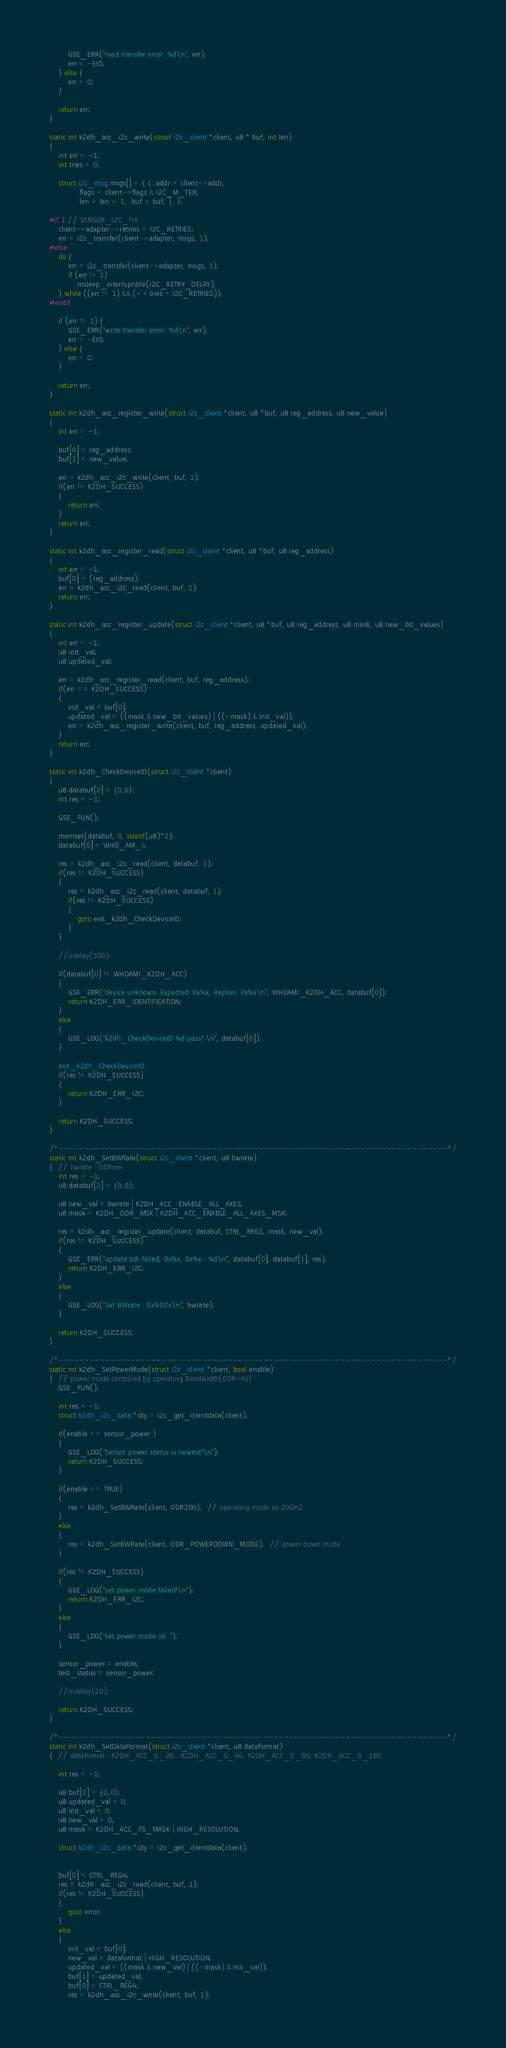Convert code to text. <code><loc_0><loc_0><loc_500><loc_500><_C_>        GSE_ERR("read transfer error: %d\n", err);
        err = -EIO;
    } else {
        err = 0;
    }

    return err;
}

static int k2dh_acc_i2c_write(struct i2c_client *client, u8 * buf, int len)
{
    int err = -1;
    int tries = 0;

    struct i2c_msg msgs[] = { { .addr = client->addr,
            .flags = client->flags & I2C_M_TEN,
            .len = len + 1, .buf = buf, }, };

#if 1 // SENSOR_I2C_FIX
	client->adapter->retries = I2C_RETRIES;
	err = i2c_transfer(client->adapter, msgs, 1);
#else
    do {
        err = i2c_transfer(client->adapter, msgs, 1);
        if (err != 1)
            msleep_interruptible(I2C_RETRY_DELAY);
    } while ((err != 1) && (++tries < I2C_RETRIES));
#endif

    if (err != 1) {
        GSE_ERR("write transfer error: %d\n", err);
        err = -EIO;
    } else {
        err = 0;
    }

    return err;
}

static int k2dh_acc_register_write(struct i2c_client *client, u8 *buf, u8 reg_address, u8 new_value)
{
    int err = -1;

    buf[0] = reg_address;
    buf[1] = new_value;

    err = k2dh_acc_i2c_write(client, buf, 1);
    if(err != K2DH_SUCCESS)
    {
        return err;
    }
    return err;
}

static int k2dh_acc_register_read(struct i2c_client *client, u8 *buf, u8 reg_address)
{
    int err = -1;
    buf[0] = (reg_address);
    err = k2dh_acc_i2c_read(client, buf, 1);
    return err;
}

static int k2dh_acc_register_update(struct i2c_client *client, u8 *buf, u8 reg_address, u8 mask, u8 new_bit_values)
{
    int err = -1;
    u8 init_val;
    u8 updated_val;

    err = k2dh_acc_register_read(client, buf, reg_address);
    if(err == K2DH_SUCCESS)
    {
        init_val = buf[0];
        updated_val = ((mask & new_bit_values) | ((~mask) & init_val));
        err = k2dh_acc_register_write(client, buf, reg_address, updated_val);
    }
    return err;
}

static int k2dh_CheckDeviceID(struct i2c_client *client)
{
    u8 databuf[2] = {0,0};
    int res = -1;

    GSE_FUN();

    memset(databuf, 0, sizeof(u8)*2);
    databuf[0] = WHO_AM_I;

    res = k2dh_acc_i2c_read(client, databuf, 1);
    if(res != K2DH_SUCCESS)
    {
        res = k2dh_acc_i2c_read(client, databuf, 1);
        if(res != K2DH_SUCCESS)
        {
            goto exit_k2dh_CheckDeviceID;
        }
    }

    //udelay(500);

    if(databuf[0] != WHOAMI_K2DH_ACC)
    {
        GSE_ERR("device unknown. Expected: 0x%x, Replies: 0x%x\n", WHOAMI_K2DH_ACC, databuf[0]);
        return K2DH_ERR_IDENTIFICATION;
    }
    else
    {
        GSE_LOG("k2dh_CheckDeviceID %d pass! \n", databuf[0]);
    }

    exit_k2dh_CheckDeviceID:
    if(res != K2DH_SUCCESS)
    {
        return K2DH_ERR_I2C;
    }

    return K2DH_SUCCESS;
}

/*----------------------------------------------------------------------------*/
static int k2dh_SetBWRate(struct i2c_client *client, u8 bwrate)
{  // bwrate : ODRxxx
    int res = -1;
    u8 databuf[2] = {0,0};

    u8 new_val = bwrate | K2DH_ACC_ENABLE_ALL_AXES;
    u8 mask = K2DH_ODR_MSK | K2DH_ACC_ENABLE_ALL_AXES_MSK;

    res = k2dh_acc_register_update(client, databuf, CTRL_REG1, mask, new_val);
    if(res != K2DH_SUCCESS)
    {
        GSE_ERR("update odr failed, 0x%x, 0x%x : %d\n", databuf[0], databuf[1], res);
        return K2DH_ERR_I2C;
    }
    else
    {
        GSE_LOG("Set BWrate : 0x%02x\n", bwrate);
    }

    return K2DH_SUCCESS;
}

/*----------------------------------------------------------------------------*/
static int k2dh_SetPowerMode(struct i2c_client *client, bool enable)
{  // power mode controled by operating Bandwidth(ODR-Hz)
    GSE_FUN();

    int res = -1;
    struct k2dh_i2c_data *obj = i2c_get_clientdata(client);

    if(enable == sensor_power )
    {
        GSE_LOG("Sensor power status is newest!\n");
        return K2DH_SUCCESS;
    }

    if(enable == TRUE)
    {
        res = k2dh_SetBWRate(client, ODR200);  // operating mode as 200HZ
    }
    else
    {
        res = k2dh_SetBWRate(client, ODR_POWERDOWN_MODE);  // power down mode
    }

    if(res != K2DH_SUCCESS)
    {
        GSE_LOG("set power mode failed!\n");
        return K2DH_ERR_I2C;
    }
    else
    {
        GSE_LOG("set power mode ok: ");
    }

    sensor_power = enable;
    test_status = sensor_power;

    //mdelay(20);

    return K2DH_SUCCESS;
}

/*----------------------------------------------------------------------------*/
static int k2dh_SetDataFormat(struct i2c_client *client, u8 dataformat)
{  // dataformat : K2DH_ACC_G_2G . K2DH_ACC_G_4G. K2DH_ACC_G_8G. K2DH_ACC_G_16G

    int res = -1;

    u8 buf[2] = {0,0};
    u8 updated_val = 0;
    u8 init_val = 0;
    u8 new_val = 0;
    u8 mask = K2DH_ACC_FS_MASK | HIGH_RESOLUTION;

    struct k2dh_i2c_data *obj = i2c_get_clientdata(client);


    buf[0] = CTRL_REG4;
    res = k2dh_acc_i2c_read(client, buf, 1);
    if(res != K2DH_SUCCESS)
    {
        goto error;
    }
    else
    {
        init_val = buf[0];
        new_val = dataformat | HIGH_RESOLUTION;
        updated_val = ((mask & new_val) | ((~mask) & init_val));
        buf[1] = updated_val;
        buf[0] = CTRL_REG4;
        res = k2dh_acc_i2c_write(client, buf, 1);</code> 